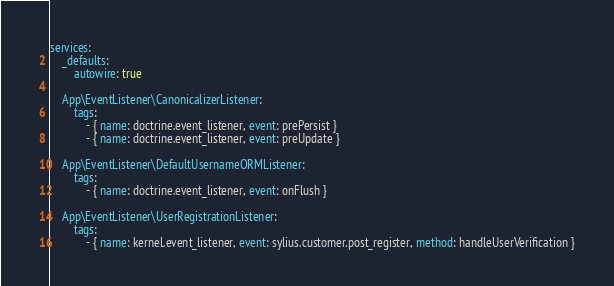<code> <loc_0><loc_0><loc_500><loc_500><_YAML_>services:
    _defaults:
        autowire: true

    App\EventListener\CanonicalizerListener:
        tags:
            - { name: doctrine.event_listener, event: prePersist }
            - { name: doctrine.event_listener, event: preUpdate }

    App\EventListener\DefaultUsernameORMListener:
        tags:
            - { name: doctrine.event_listener, event: onFlush }

    App\EventListener\UserRegistrationListener:
        tags:
            - { name: kernel.event_listener, event: sylius.customer.post_register, method: handleUserVerification }
</code> 